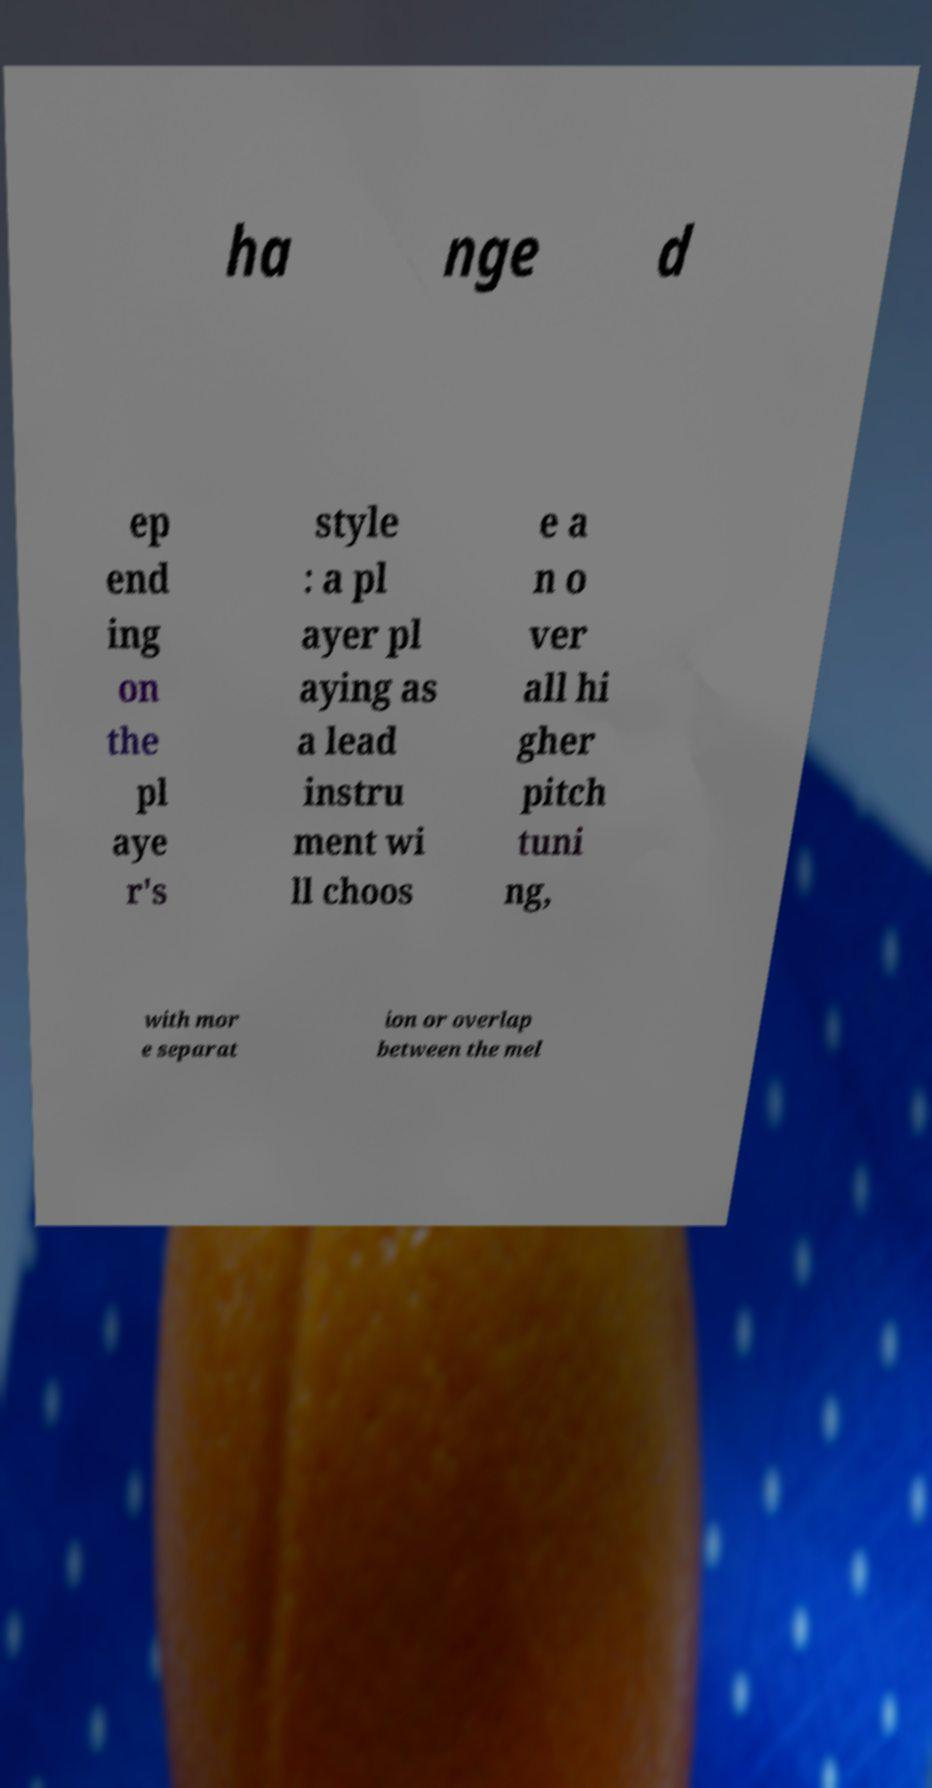There's text embedded in this image that I need extracted. Can you transcribe it verbatim? ha nge d ep end ing on the pl aye r's style : a pl ayer pl aying as a lead instru ment wi ll choos e a n o ver all hi gher pitch tuni ng, with mor e separat ion or overlap between the mel 